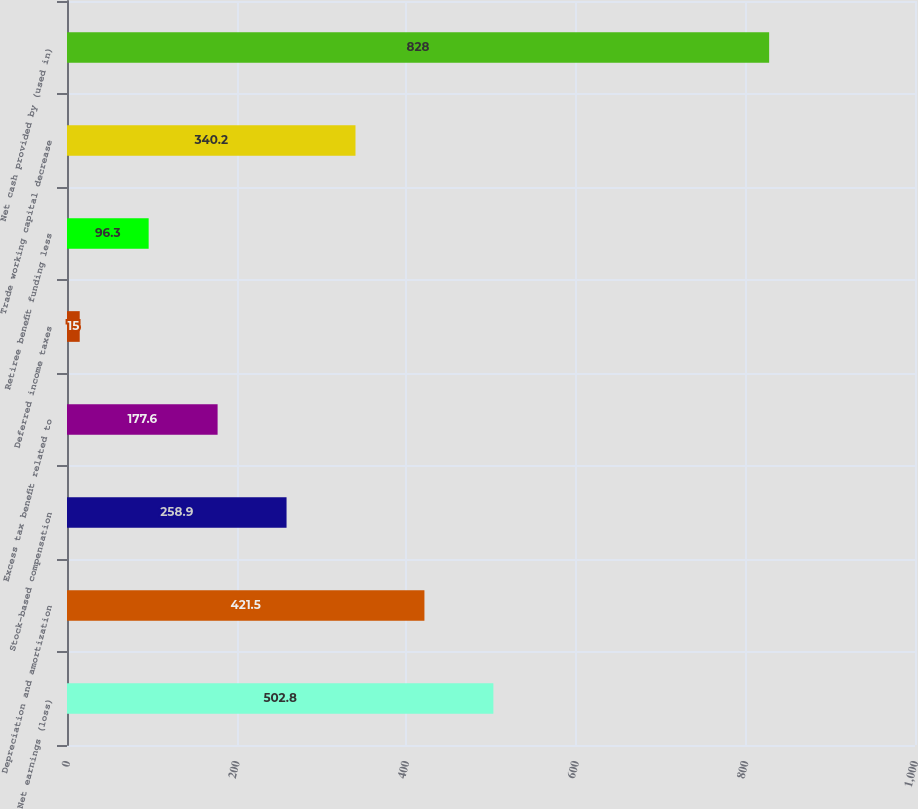Convert chart to OTSL. <chart><loc_0><loc_0><loc_500><loc_500><bar_chart><fcel>Net earnings (loss)<fcel>Depreciation and amortization<fcel>Stock-based compensation<fcel>Excess tax benefit related to<fcel>Deferred income taxes<fcel>Retiree benefit funding less<fcel>Trade working capital decrease<fcel>Net cash provided by (used in)<nl><fcel>502.8<fcel>421.5<fcel>258.9<fcel>177.6<fcel>15<fcel>96.3<fcel>340.2<fcel>828<nl></chart> 